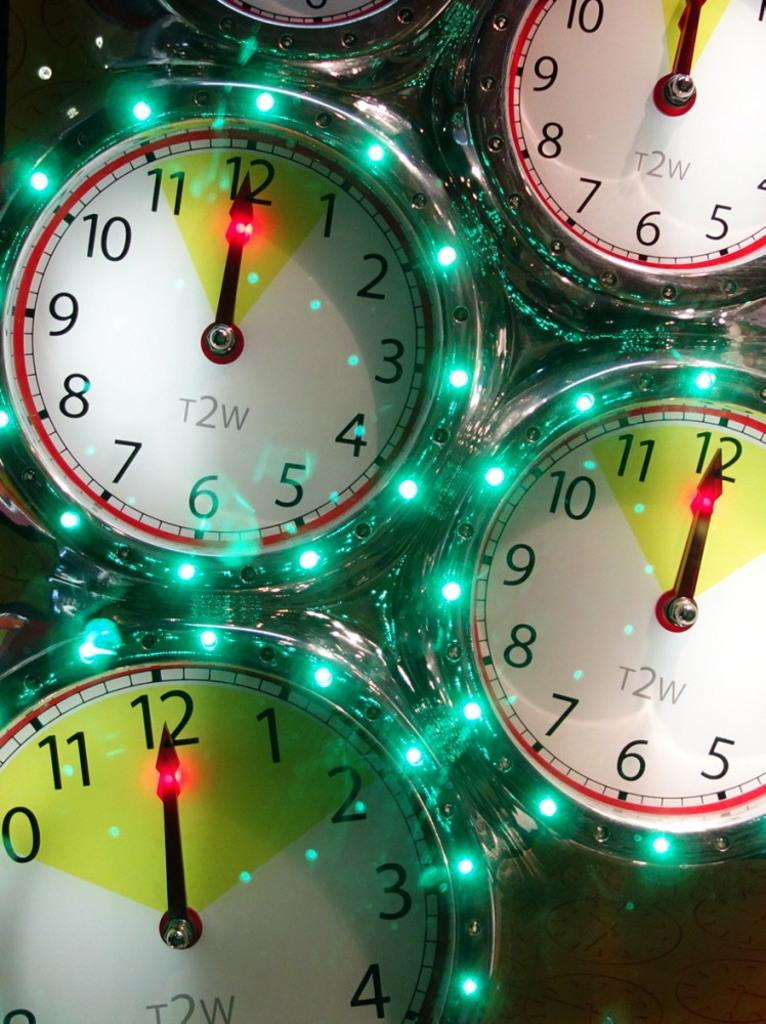Provide a one-sentence caption for the provided image. All of the clocks in the image read exactly at 12 o'clock. 